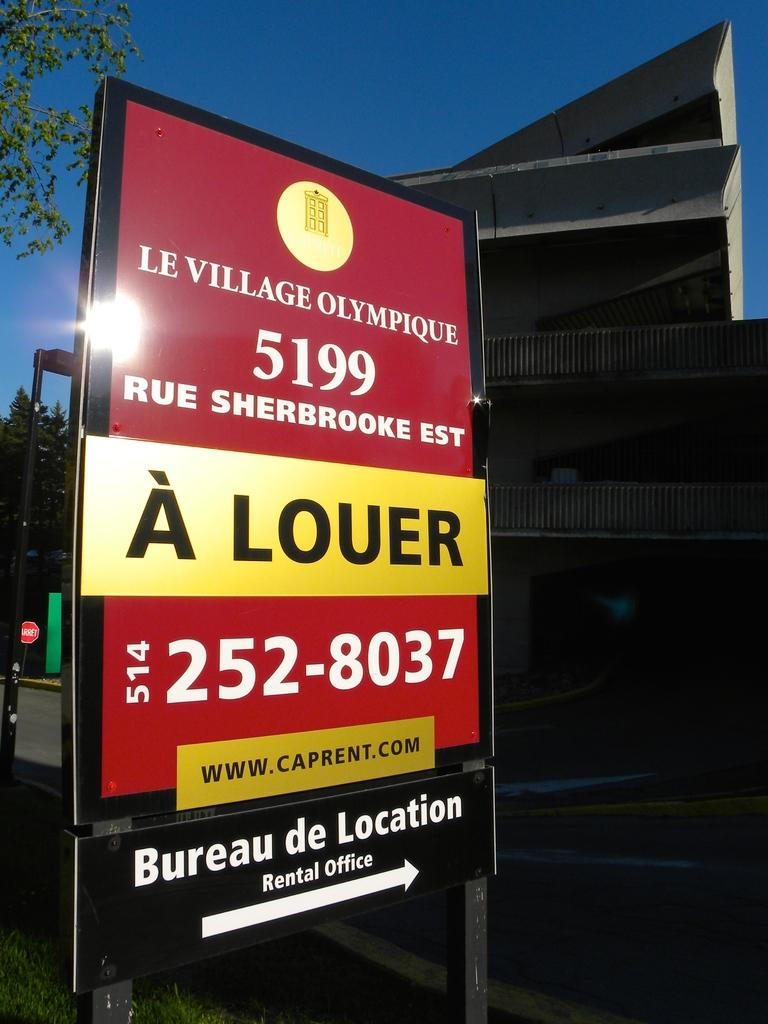<image>
Relay a brief, clear account of the picture shown. A sign in French shows the way to the rental office for the Olympic Village. 